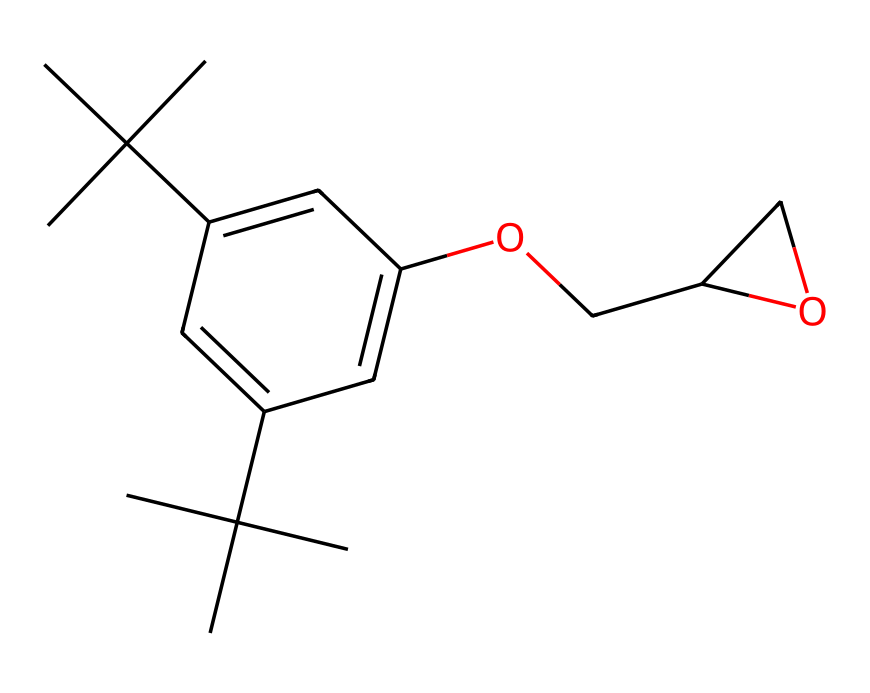What is the molecular formula of this compound? To determine the molecular formula, we count the number of each type of atom represented in the chemical structure. The structure contains 15 carbon (C) atoms, 28 hydrogen (H) atoms, and 2 oxygen (O) atoms. Thus, the formula is C15H28O2.
Answer: C15H28O2 How many rings are present in the structure? By analyzing the SMILES representation, we observe that there is one cyclohexane ring indicated by the numbering "1". This shows that there’s a cyclic structure present.
Answer: 1 What functional groups are present in this compound? Examining the structure, we identify an ether group (-O-) from the -OCC sequence and a hydroxy group (-OH) from the presence of the -O at the aromatic ring. This suggests primary alcohol and ether functionalities.
Answer: ether and alcohol What is the significance of the phenolic structure in this compound? The phenolic structure, which includes the hydroxyl group on an aromatic ring, can contribute to the compound’s antioxidant properties and may enhance its compatibility with biological tissues in prosthetic applications.
Answer: antioxidant properties What might be the expected solubility of this compound in water? Given the presence of the hydrophobic carbon chains and the hydrophilic hydroxyl group, we deduce that the compound is likely to be poorly soluble in water due to the dominating hydrophobic character.
Answer: poor solubility What type of chemical is this, based on its structural features? The presence of multiple carbon chains and distinct functional groups, including an alcohol and ether, classifies this compound as a medicinal compound or a biologically active small molecule.
Answer: medicinal compound What properties could the branched alkane segments contribute to in a prosthetic material? The branched alkane segments enhance flexibility and strength, reducing brittleness and improving the mechanical properties of the material, essential for prosthetics that require durability and light weight.
Answer: flexibility and strength 